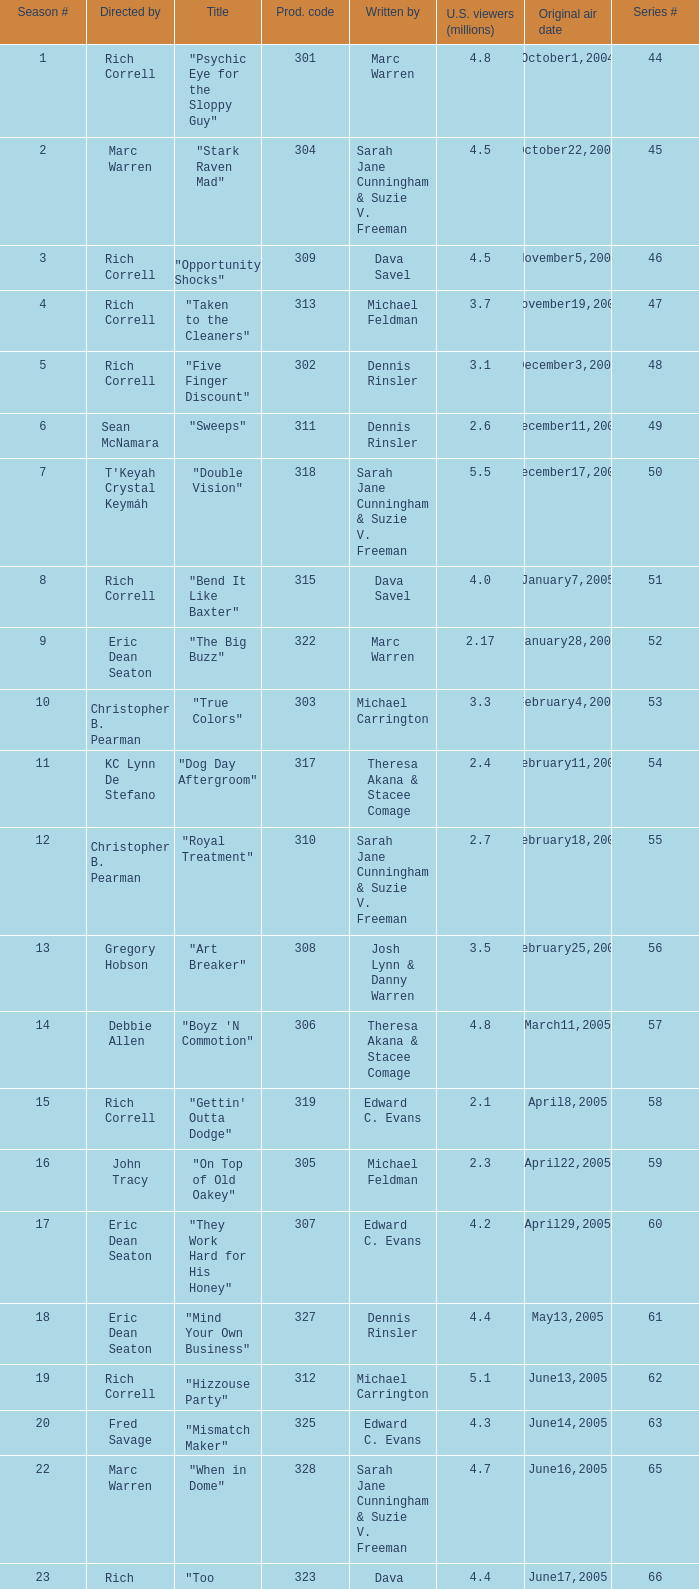Parse the full table. {'header': ['Season #', 'Directed by', 'Title', 'Prod. code', 'Written by', 'U.S. viewers (millions)', 'Original air date', 'Series #'], 'rows': [['1', 'Rich Correll', '"Psychic Eye for the Sloppy Guy"', '301', 'Marc Warren', '4.8', 'October1,2004', '44'], ['2', 'Marc Warren', '"Stark Raven Mad"', '304', 'Sarah Jane Cunningham & Suzie V. Freeman', '4.5', 'October22,2004', '45'], ['3', 'Rich Correll', '"Opportunity Shocks"', '309', 'Dava Savel', '4.5', 'November5,2004', '46'], ['4', 'Rich Correll', '"Taken to the Cleaners"', '313', 'Michael Feldman', '3.7', 'November19,2004', '47'], ['5', 'Rich Correll', '"Five Finger Discount"', '302', 'Dennis Rinsler', '3.1', 'December3,2004', '48'], ['6', 'Sean McNamara', '"Sweeps"', '311', 'Dennis Rinsler', '2.6', 'December11,2004', '49'], ['7', "T'Keyah Crystal Keymáh", '"Double Vision"', '318', 'Sarah Jane Cunningham & Suzie V. Freeman', '5.5', 'December17,2004', '50'], ['8', 'Rich Correll', '"Bend It Like Baxter"', '315', 'Dava Savel', '4.0', 'January7,2005', '51'], ['9', 'Eric Dean Seaton', '"The Big Buzz"', '322', 'Marc Warren', '2.17', 'January28,2005', '52'], ['10', 'Christopher B. Pearman', '"True Colors"', '303', 'Michael Carrington', '3.3', 'February4,2005', '53'], ['11', 'KC Lynn De Stefano', '"Dog Day Aftergroom"', '317', 'Theresa Akana & Stacee Comage', '2.4', 'February11,2005', '54'], ['12', 'Christopher B. Pearman', '"Royal Treatment"', '310', 'Sarah Jane Cunningham & Suzie V. Freeman', '2.7', 'February18,2005', '55'], ['13', 'Gregory Hobson', '"Art Breaker"', '308', 'Josh Lynn & Danny Warren', '3.5', 'February25,2005', '56'], ['14', 'Debbie Allen', '"Boyz \'N Commotion"', '306', 'Theresa Akana & Stacee Comage', '4.8', 'March11,2005', '57'], ['15', 'Rich Correll', '"Gettin\' Outta Dodge"', '319', 'Edward C. Evans', '2.1', 'April8,2005', '58'], ['16', 'John Tracy', '"On Top of Old Oakey"', '305', 'Michael Feldman', '2.3', 'April22,2005', '59'], ['17', 'Eric Dean Seaton', '"They Work Hard for His Honey"', '307', 'Edward C. Evans', '4.2', 'April29,2005', '60'], ['18', 'Eric Dean Seaton', '"Mind Your Own Business"', '327', 'Dennis Rinsler', '4.4', 'May13,2005', '61'], ['19', 'Rich Correll', '"Hizzouse Party"', '312', 'Michael Carrington', '5.1', 'June13,2005', '62'], ['20', 'Fred Savage', '"Mismatch Maker"', '325', 'Edward C. Evans', '4.3', 'June14,2005', '63'], ['22', 'Marc Warren', '"When in Dome"', '328', 'Sarah Jane Cunningham & Suzie V. Freeman', '4.7', 'June16,2005', '65'], ['23', 'Rich Correll', '"Too Much Pressure"', '323', 'Dava Savel', '4.4', 'June17,2005', '66'], ['24', 'Rich Correll', '"Extreme Cory"', '326', 'Theresa Akana & Stacee Comage', '3.8', 'July8,2005', '67'], ['25', 'Sean McNamara', '"The Grill Next Door"', '324', 'Michael Feldman', '4.23', 'July8,2005', '68'], ['26', 'Sean McNamara', '"Point of No Return"', '330', 'Edward C. Evans', '6.0', 'July23,2005', '69'], ['29', 'Rich Correll', '"Food for Thought"', '316', 'Marc Warren', '3.4', 'September18,2005', '72'], ['30', 'Rich Correll', '"Mr. Perfect"', '329', 'Michael Carrington', '3.0', 'October7,2005', '73'], ['31', 'Rich Correll', '"Goin\' Hollywood"', '333', 'Dennis Rinsler & Marc Warren', '3.7', 'November4,2005', '74'], ['32', 'Sean McNamara', '"Save the Last Dance"', '334', 'Marc Warren', '3.3', 'November25,2005', '75'], ['33', 'Rondell Sheridan', '"Cake Fear"', '332', 'Theresa Akana & Stacee Comage', '3.6', 'December16,2005', '76'], ['34', 'Marc Warren', '"Vision Impossible"', '335', 'David Brookwell & Sean McNamara', '4.7', 'January6,2006', '77']]} What is the title of the episode directed by Rich Correll and written by Dennis Rinsler? "Five Finger Discount". 